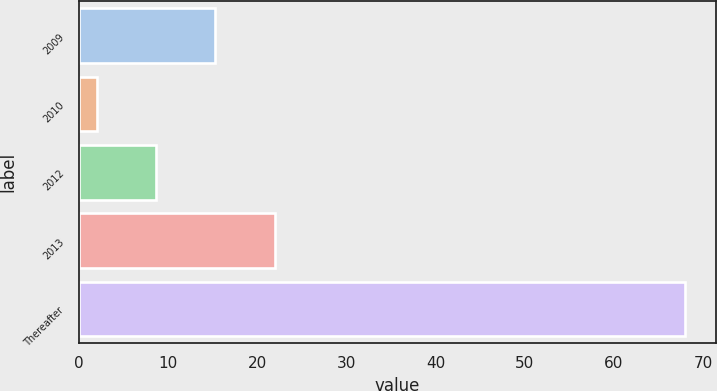Convert chart to OTSL. <chart><loc_0><loc_0><loc_500><loc_500><bar_chart><fcel>2009<fcel>2010<fcel>2012<fcel>2013<fcel>Thereafter<nl><fcel>15.2<fcel>2<fcel>8.6<fcel>22<fcel>68<nl></chart> 